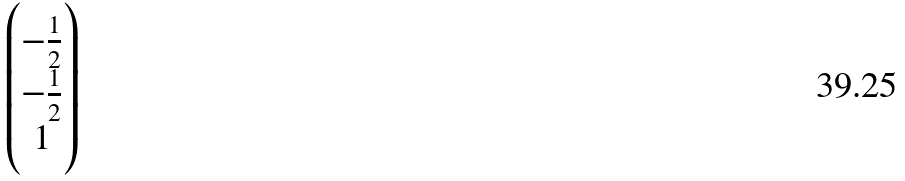<formula> <loc_0><loc_0><loc_500><loc_500>\begin{pmatrix} - \frac { 1 } { 2 } \\ - \frac { 1 } { 2 } \\ 1 \end{pmatrix}</formula> 